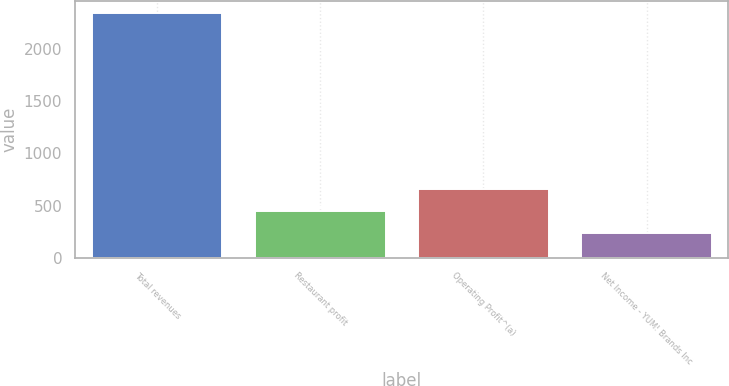Convert chart. <chart><loc_0><loc_0><loc_500><loc_500><bar_chart><fcel>Total revenues<fcel>Restaurant profit<fcel>Operating Profit^(a)<fcel>Net Income - YUM! Brands Inc<nl><fcel>2345<fcel>451.4<fcel>661.8<fcel>241<nl></chart> 